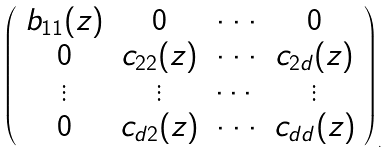<formula> <loc_0><loc_0><loc_500><loc_500>\left ( \begin{array} { c c c c } b _ { 1 1 } ( z ) & 0 & \cdot \cdot \cdot & 0 \\ 0 & c _ { 2 2 } ( z ) & \cdot \cdot \cdot & c _ { 2 d } ( z ) \\ \vdots & \vdots & \cdots & \vdots \\ 0 & c _ { d 2 } ( z ) & \cdot \cdot \cdot & c _ { d d } ( z ) \end{array} \right ) _ { . }</formula> 